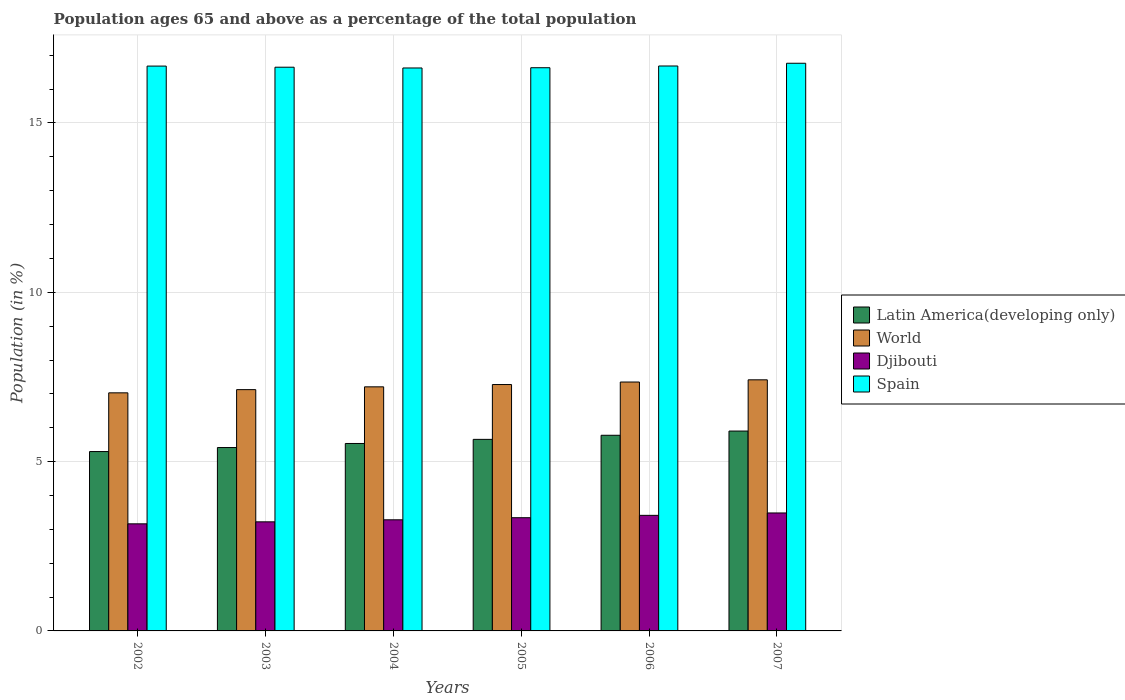How many different coloured bars are there?
Offer a very short reply. 4. Are the number of bars per tick equal to the number of legend labels?
Ensure brevity in your answer.  Yes. Are the number of bars on each tick of the X-axis equal?
Provide a short and direct response. Yes. In how many cases, is the number of bars for a given year not equal to the number of legend labels?
Keep it short and to the point. 0. What is the percentage of the population ages 65 and above in Djibouti in 2006?
Keep it short and to the point. 3.41. Across all years, what is the maximum percentage of the population ages 65 and above in World?
Provide a short and direct response. 7.41. Across all years, what is the minimum percentage of the population ages 65 and above in Djibouti?
Ensure brevity in your answer.  3.16. In which year was the percentage of the population ages 65 and above in World minimum?
Provide a short and direct response. 2002. What is the total percentage of the population ages 65 and above in Spain in the graph?
Provide a short and direct response. 100.03. What is the difference between the percentage of the population ages 65 and above in Latin America(developing only) in 2004 and that in 2005?
Your response must be concise. -0.12. What is the difference between the percentage of the population ages 65 and above in World in 2007 and the percentage of the population ages 65 and above in Spain in 2004?
Your response must be concise. -9.21. What is the average percentage of the population ages 65 and above in Latin America(developing only) per year?
Ensure brevity in your answer.  5.6. In the year 2002, what is the difference between the percentage of the population ages 65 and above in World and percentage of the population ages 65 and above in Spain?
Give a very brief answer. -9.65. What is the ratio of the percentage of the population ages 65 and above in Latin America(developing only) in 2006 to that in 2007?
Ensure brevity in your answer.  0.98. What is the difference between the highest and the second highest percentage of the population ages 65 and above in World?
Offer a terse response. 0.06. What is the difference between the highest and the lowest percentage of the population ages 65 and above in Djibouti?
Your response must be concise. 0.32. Is the sum of the percentage of the population ages 65 and above in Latin America(developing only) in 2003 and 2006 greater than the maximum percentage of the population ages 65 and above in Djibouti across all years?
Give a very brief answer. Yes. What does the 3rd bar from the left in 2002 represents?
Ensure brevity in your answer.  Djibouti. What does the 4th bar from the right in 2005 represents?
Provide a short and direct response. Latin America(developing only). Is it the case that in every year, the sum of the percentage of the population ages 65 and above in Djibouti and percentage of the population ages 65 and above in Latin America(developing only) is greater than the percentage of the population ages 65 and above in Spain?
Keep it short and to the point. No. What is the difference between two consecutive major ticks on the Y-axis?
Your answer should be very brief. 5. Does the graph contain any zero values?
Ensure brevity in your answer.  No. Does the graph contain grids?
Keep it short and to the point. Yes. Where does the legend appear in the graph?
Provide a succinct answer. Center right. How many legend labels are there?
Your answer should be compact. 4. How are the legend labels stacked?
Keep it short and to the point. Vertical. What is the title of the graph?
Make the answer very short. Population ages 65 and above as a percentage of the total population. What is the label or title of the Y-axis?
Your answer should be compact. Population (in %). What is the Population (in %) of Latin America(developing only) in 2002?
Your response must be concise. 5.3. What is the Population (in %) in World in 2002?
Your answer should be compact. 7.03. What is the Population (in %) of Djibouti in 2002?
Offer a very short reply. 3.16. What is the Population (in %) of Spain in 2002?
Your answer should be very brief. 16.68. What is the Population (in %) of Latin America(developing only) in 2003?
Offer a terse response. 5.42. What is the Population (in %) in World in 2003?
Keep it short and to the point. 7.13. What is the Population (in %) of Djibouti in 2003?
Provide a short and direct response. 3.22. What is the Population (in %) of Spain in 2003?
Your answer should be very brief. 16.65. What is the Population (in %) in Latin America(developing only) in 2004?
Ensure brevity in your answer.  5.54. What is the Population (in %) of World in 2004?
Provide a succinct answer. 7.21. What is the Population (in %) of Djibouti in 2004?
Provide a short and direct response. 3.28. What is the Population (in %) in Spain in 2004?
Your response must be concise. 16.62. What is the Population (in %) in Latin America(developing only) in 2005?
Your answer should be very brief. 5.66. What is the Population (in %) of World in 2005?
Provide a short and direct response. 7.28. What is the Population (in %) of Djibouti in 2005?
Give a very brief answer. 3.34. What is the Population (in %) of Spain in 2005?
Your response must be concise. 16.63. What is the Population (in %) of Latin America(developing only) in 2006?
Offer a very short reply. 5.78. What is the Population (in %) in World in 2006?
Provide a succinct answer. 7.35. What is the Population (in %) of Djibouti in 2006?
Provide a succinct answer. 3.41. What is the Population (in %) of Spain in 2006?
Make the answer very short. 16.68. What is the Population (in %) of Latin America(developing only) in 2007?
Offer a terse response. 5.9. What is the Population (in %) in World in 2007?
Give a very brief answer. 7.41. What is the Population (in %) in Djibouti in 2007?
Ensure brevity in your answer.  3.48. What is the Population (in %) in Spain in 2007?
Your answer should be very brief. 16.76. Across all years, what is the maximum Population (in %) of Latin America(developing only)?
Provide a succinct answer. 5.9. Across all years, what is the maximum Population (in %) in World?
Provide a succinct answer. 7.41. Across all years, what is the maximum Population (in %) in Djibouti?
Keep it short and to the point. 3.48. Across all years, what is the maximum Population (in %) of Spain?
Give a very brief answer. 16.76. Across all years, what is the minimum Population (in %) in Latin America(developing only)?
Give a very brief answer. 5.3. Across all years, what is the minimum Population (in %) in World?
Ensure brevity in your answer.  7.03. Across all years, what is the minimum Population (in %) of Djibouti?
Give a very brief answer. 3.16. Across all years, what is the minimum Population (in %) in Spain?
Provide a succinct answer. 16.62. What is the total Population (in %) in Latin America(developing only) in the graph?
Your answer should be very brief. 33.58. What is the total Population (in %) of World in the graph?
Keep it short and to the point. 43.4. What is the total Population (in %) of Djibouti in the graph?
Offer a terse response. 19.9. What is the total Population (in %) in Spain in the graph?
Provide a succinct answer. 100.03. What is the difference between the Population (in %) of Latin America(developing only) in 2002 and that in 2003?
Keep it short and to the point. -0.12. What is the difference between the Population (in %) of World in 2002 and that in 2003?
Give a very brief answer. -0.09. What is the difference between the Population (in %) of Djibouti in 2002 and that in 2003?
Offer a terse response. -0.06. What is the difference between the Population (in %) in Spain in 2002 and that in 2003?
Give a very brief answer. 0.03. What is the difference between the Population (in %) of Latin America(developing only) in 2002 and that in 2004?
Your answer should be very brief. -0.24. What is the difference between the Population (in %) of World in 2002 and that in 2004?
Provide a short and direct response. -0.18. What is the difference between the Population (in %) of Djibouti in 2002 and that in 2004?
Make the answer very short. -0.12. What is the difference between the Population (in %) in Spain in 2002 and that in 2004?
Ensure brevity in your answer.  0.06. What is the difference between the Population (in %) in Latin America(developing only) in 2002 and that in 2005?
Offer a terse response. -0.36. What is the difference between the Population (in %) in World in 2002 and that in 2005?
Offer a terse response. -0.24. What is the difference between the Population (in %) of Djibouti in 2002 and that in 2005?
Ensure brevity in your answer.  -0.18. What is the difference between the Population (in %) in Spain in 2002 and that in 2005?
Offer a terse response. 0.05. What is the difference between the Population (in %) in Latin America(developing only) in 2002 and that in 2006?
Your answer should be compact. -0.48. What is the difference between the Population (in %) of World in 2002 and that in 2006?
Your answer should be compact. -0.32. What is the difference between the Population (in %) of Djibouti in 2002 and that in 2006?
Ensure brevity in your answer.  -0.25. What is the difference between the Population (in %) of Spain in 2002 and that in 2006?
Provide a succinct answer. -0. What is the difference between the Population (in %) in Latin America(developing only) in 2002 and that in 2007?
Your response must be concise. -0.61. What is the difference between the Population (in %) in World in 2002 and that in 2007?
Provide a succinct answer. -0.38. What is the difference between the Population (in %) of Djibouti in 2002 and that in 2007?
Offer a very short reply. -0.32. What is the difference between the Population (in %) in Spain in 2002 and that in 2007?
Make the answer very short. -0.08. What is the difference between the Population (in %) of Latin America(developing only) in 2003 and that in 2004?
Your response must be concise. -0.12. What is the difference between the Population (in %) of World in 2003 and that in 2004?
Offer a very short reply. -0.08. What is the difference between the Population (in %) of Djibouti in 2003 and that in 2004?
Ensure brevity in your answer.  -0.06. What is the difference between the Population (in %) in Spain in 2003 and that in 2004?
Make the answer very short. 0.02. What is the difference between the Population (in %) in Latin America(developing only) in 2003 and that in 2005?
Your response must be concise. -0.24. What is the difference between the Population (in %) in World in 2003 and that in 2005?
Provide a succinct answer. -0.15. What is the difference between the Population (in %) in Djibouti in 2003 and that in 2005?
Your answer should be very brief. -0.12. What is the difference between the Population (in %) of Spain in 2003 and that in 2005?
Give a very brief answer. 0.02. What is the difference between the Population (in %) in Latin America(developing only) in 2003 and that in 2006?
Your answer should be very brief. -0.36. What is the difference between the Population (in %) in World in 2003 and that in 2006?
Provide a succinct answer. -0.22. What is the difference between the Population (in %) in Djibouti in 2003 and that in 2006?
Provide a short and direct response. -0.19. What is the difference between the Population (in %) of Spain in 2003 and that in 2006?
Your answer should be very brief. -0.04. What is the difference between the Population (in %) of Latin America(developing only) in 2003 and that in 2007?
Make the answer very short. -0.49. What is the difference between the Population (in %) in World in 2003 and that in 2007?
Offer a terse response. -0.29. What is the difference between the Population (in %) in Djibouti in 2003 and that in 2007?
Provide a short and direct response. -0.26. What is the difference between the Population (in %) in Spain in 2003 and that in 2007?
Give a very brief answer. -0.12. What is the difference between the Population (in %) in Latin America(developing only) in 2004 and that in 2005?
Provide a succinct answer. -0.12. What is the difference between the Population (in %) of World in 2004 and that in 2005?
Give a very brief answer. -0.07. What is the difference between the Population (in %) in Djibouti in 2004 and that in 2005?
Give a very brief answer. -0.06. What is the difference between the Population (in %) in Spain in 2004 and that in 2005?
Give a very brief answer. -0.01. What is the difference between the Population (in %) of Latin America(developing only) in 2004 and that in 2006?
Provide a short and direct response. -0.24. What is the difference between the Population (in %) in World in 2004 and that in 2006?
Offer a very short reply. -0.14. What is the difference between the Population (in %) in Djibouti in 2004 and that in 2006?
Offer a terse response. -0.13. What is the difference between the Population (in %) of Spain in 2004 and that in 2006?
Your answer should be compact. -0.06. What is the difference between the Population (in %) of Latin America(developing only) in 2004 and that in 2007?
Your response must be concise. -0.37. What is the difference between the Population (in %) in World in 2004 and that in 2007?
Ensure brevity in your answer.  -0.21. What is the difference between the Population (in %) in Djibouti in 2004 and that in 2007?
Give a very brief answer. -0.2. What is the difference between the Population (in %) in Spain in 2004 and that in 2007?
Provide a succinct answer. -0.14. What is the difference between the Population (in %) of Latin America(developing only) in 2005 and that in 2006?
Give a very brief answer. -0.12. What is the difference between the Population (in %) of World in 2005 and that in 2006?
Keep it short and to the point. -0.07. What is the difference between the Population (in %) of Djibouti in 2005 and that in 2006?
Ensure brevity in your answer.  -0.07. What is the difference between the Population (in %) of Spain in 2005 and that in 2006?
Give a very brief answer. -0.05. What is the difference between the Population (in %) of Latin America(developing only) in 2005 and that in 2007?
Make the answer very short. -0.25. What is the difference between the Population (in %) in World in 2005 and that in 2007?
Give a very brief answer. -0.14. What is the difference between the Population (in %) of Djibouti in 2005 and that in 2007?
Your answer should be very brief. -0.14. What is the difference between the Population (in %) of Spain in 2005 and that in 2007?
Your answer should be very brief. -0.13. What is the difference between the Population (in %) of Latin America(developing only) in 2006 and that in 2007?
Give a very brief answer. -0.12. What is the difference between the Population (in %) of World in 2006 and that in 2007?
Your answer should be compact. -0.06. What is the difference between the Population (in %) in Djibouti in 2006 and that in 2007?
Keep it short and to the point. -0.07. What is the difference between the Population (in %) of Spain in 2006 and that in 2007?
Your answer should be very brief. -0.08. What is the difference between the Population (in %) of Latin America(developing only) in 2002 and the Population (in %) of World in 2003?
Give a very brief answer. -1.83. What is the difference between the Population (in %) in Latin America(developing only) in 2002 and the Population (in %) in Djibouti in 2003?
Keep it short and to the point. 2.08. What is the difference between the Population (in %) of Latin America(developing only) in 2002 and the Population (in %) of Spain in 2003?
Provide a succinct answer. -11.35. What is the difference between the Population (in %) of World in 2002 and the Population (in %) of Djibouti in 2003?
Provide a short and direct response. 3.81. What is the difference between the Population (in %) of World in 2002 and the Population (in %) of Spain in 2003?
Offer a terse response. -9.62. What is the difference between the Population (in %) in Djibouti in 2002 and the Population (in %) in Spain in 2003?
Give a very brief answer. -13.48. What is the difference between the Population (in %) in Latin America(developing only) in 2002 and the Population (in %) in World in 2004?
Give a very brief answer. -1.91. What is the difference between the Population (in %) of Latin America(developing only) in 2002 and the Population (in %) of Djibouti in 2004?
Keep it short and to the point. 2.02. What is the difference between the Population (in %) in Latin America(developing only) in 2002 and the Population (in %) in Spain in 2004?
Your response must be concise. -11.33. What is the difference between the Population (in %) of World in 2002 and the Population (in %) of Djibouti in 2004?
Give a very brief answer. 3.75. What is the difference between the Population (in %) of World in 2002 and the Population (in %) of Spain in 2004?
Your response must be concise. -9.59. What is the difference between the Population (in %) in Djibouti in 2002 and the Population (in %) in Spain in 2004?
Your response must be concise. -13.46. What is the difference between the Population (in %) in Latin America(developing only) in 2002 and the Population (in %) in World in 2005?
Your response must be concise. -1.98. What is the difference between the Population (in %) of Latin America(developing only) in 2002 and the Population (in %) of Djibouti in 2005?
Your answer should be very brief. 1.95. What is the difference between the Population (in %) in Latin America(developing only) in 2002 and the Population (in %) in Spain in 2005?
Give a very brief answer. -11.33. What is the difference between the Population (in %) in World in 2002 and the Population (in %) in Djibouti in 2005?
Keep it short and to the point. 3.69. What is the difference between the Population (in %) in World in 2002 and the Population (in %) in Spain in 2005?
Give a very brief answer. -9.6. What is the difference between the Population (in %) of Djibouti in 2002 and the Population (in %) of Spain in 2005?
Your response must be concise. -13.47. What is the difference between the Population (in %) in Latin America(developing only) in 2002 and the Population (in %) in World in 2006?
Offer a very short reply. -2.05. What is the difference between the Population (in %) of Latin America(developing only) in 2002 and the Population (in %) of Djibouti in 2006?
Ensure brevity in your answer.  1.88. What is the difference between the Population (in %) in Latin America(developing only) in 2002 and the Population (in %) in Spain in 2006?
Your answer should be compact. -11.39. What is the difference between the Population (in %) in World in 2002 and the Population (in %) in Djibouti in 2006?
Offer a very short reply. 3.62. What is the difference between the Population (in %) in World in 2002 and the Population (in %) in Spain in 2006?
Offer a very short reply. -9.65. What is the difference between the Population (in %) in Djibouti in 2002 and the Population (in %) in Spain in 2006?
Ensure brevity in your answer.  -13.52. What is the difference between the Population (in %) of Latin America(developing only) in 2002 and the Population (in %) of World in 2007?
Your answer should be compact. -2.12. What is the difference between the Population (in %) in Latin America(developing only) in 2002 and the Population (in %) in Djibouti in 2007?
Give a very brief answer. 1.81. What is the difference between the Population (in %) of Latin America(developing only) in 2002 and the Population (in %) of Spain in 2007?
Keep it short and to the point. -11.47. What is the difference between the Population (in %) in World in 2002 and the Population (in %) in Djibouti in 2007?
Your response must be concise. 3.55. What is the difference between the Population (in %) in World in 2002 and the Population (in %) in Spain in 2007?
Your answer should be compact. -9.73. What is the difference between the Population (in %) of Djibouti in 2002 and the Population (in %) of Spain in 2007?
Your response must be concise. -13.6. What is the difference between the Population (in %) of Latin America(developing only) in 2003 and the Population (in %) of World in 2004?
Your response must be concise. -1.79. What is the difference between the Population (in %) of Latin America(developing only) in 2003 and the Population (in %) of Djibouti in 2004?
Your answer should be very brief. 2.13. What is the difference between the Population (in %) in Latin America(developing only) in 2003 and the Population (in %) in Spain in 2004?
Your response must be concise. -11.21. What is the difference between the Population (in %) in World in 2003 and the Population (in %) in Djibouti in 2004?
Make the answer very short. 3.84. What is the difference between the Population (in %) of World in 2003 and the Population (in %) of Spain in 2004?
Ensure brevity in your answer.  -9.5. What is the difference between the Population (in %) of Djibouti in 2003 and the Population (in %) of Spain in 2004?
Offer a terse response. -13.4. What is the difference between the Population (in %) of Latin America(developing only) in 2003 and the Population (in %) of World in 2005?
Your answer should be very brief. -1.86. What is the difference between the Population (in %) of Latin America(developing only) in 2003 and the Population (in %) of Djibouti in 2005?
Offer a terse response. 2.07. What is the difference between the Population (in %) in Latin America(developing only) in 2003 and the Population (in %) in Spain in 2005?
Your response must be concise. -11.22. What is the difference between the Population (in %) in World in 2003 and the Population (in %) in Djibouti in 2005?
Offer a terse response. 3.78. What is the difference between the Population (in %) in World in 2003 and the Population (in %) in Spain in 2005?
Offer a terse response. -9.51. What is the difference between the Population (in %) of Djibouti in 2003 and the Population (in %) of Spain in 2005?
Your answer should be very brief. -13.41. What is the difference between the Population (in %) in Latin America(developing only) in 2003 and the Population (in %) in World in 2006?
Provide a succinct answer. -1.93. What is the difference between the Population (in %) in Latin America(developing only) in 2003 and the Population (in %) in Djibouti in 2006?
Offer a very short reply. 2. What is the difference between the Population (in %) of Latin America(developing only) in 2003 and the Population (in %) of Spain in 2006?
Make the answer very short. -11.27. What is the difference between the Population (in %) in World in 2003 and the Population (in %) in Djibouti in 2006?
Give a very brief answer. 3.71. What is the difference between the Population (in %) in World in 2003 and the Population (in %) in Spain in 2006?
Provide a short and direct response. -9.56. What is the difference between the Population (in %) in Djibouti in 2003 and the Population (in %) in Spain in 2006?
Provide a succinct answer. -13.46. What is the difference between the Population (in %) of Latin America(developing only) in 2003 and the Population (in %) of World in 2007?
Provide a short and direct response. -2. What is the difference between the Population (in %) of Latin America(developing only) in 2003 and the Population (in %) of Djibouti in 2007?
Offer a very short reply. 1.93. What is the difference between the Population (in %) in Latin America(developing only) in 2003 and the Population (in %) in Spain in 2007?
Offer a terse response. -11.35. What is the difference between the Population (in %) of World in 2003 and the Population (in %) of Djibouti in 2007?
Your response must be concise. 3.64. What is the difference between the Population (in %) of World in 2003 and the Population (in %) of Spain in 2007?
Provide a short and direct response. -9.64. What is the difference between the Population (in %) in Djibouti in 2003 and the Population (in %) in Spain in 2007?
Ensure brevity in your answer.  -13.54. What is the difference between the Population (in %) of Latin America(developing only) in 2004 and the Population (in %) of World in 2005?
Provide a short and direct response. -1.74. What is the difference between the Population (in %) in Latin America(developing only) in 2004 and the Population (in %) in Djibouti in 2005?
Offer a very short reply. 2.19. What is the difference between the Population (in %) in Latin America(developing only) in 2004 and the Population (in %) in Spain in 2005?
Your response must be concise. -11.1. What is the difference between the Population (in %) in World in 2004 and the Population (in %) in Djibouti in 2005?
Give a very brief answer. 3.87. What is the difference between the Population (in %) in World in 2004 and the Population (in %) in Spain in 2005?
Ensure brevity in your answer.  -9.42. What is the difference between the Population (in %) of Djibouti in 2004 and the Population (in %) of Spain in 2005?
Offer a very short reply. -13.35. What is the difference between the Population (in %) of Latin America(developing only) in 2004 and the Population (in %) of World in 2006?
Keep it short and to the point. -1.81. What is the difference between the Population (in %) in Latin America(developing only) in 2004 and the Population (in %) in Djibouti in 2006?
Make the answer very short. 2.12. What is the difference between the Population (in %) of Latin America(developing only) in 2004 and the Population (in %) of Spain in 2006?
Ensure brevity in your answer.  -11.15. What is the difference between the Population (in %) of World in 2004 and the Population (in %) of Djibouti in 2006?
Your answer should be compact. 3.8. What is the difference between the Population (in %) in World in 2004 and the Population (in %) in Spain in 2006?
Provide a succinct answer. -9.47. What is the difference between the Population (in %) of Djibouti in 2004 and the Population (in %) of Spain in 2006?
Your answer should be compact. -13.4. What is the difference between the Population (in %) in Latin America(developing only) in 2004 and the Population (in %) in World in 2007?
Your answer should be very brief. -1.88. What is the difference between the Population (in %) of Latin America(developing only) in 2004 and the Population (in %) of Djibouti in 2007?
Ensure brevity in your answer.  2.05. What is the difference between the Population (in %) of Latin America(developing only) in 2004 and the Population (in %) of Spain in 2007?
Make the answer very short. -11.23. What is the difference between the Population (in %) of World in 2004 and the Population (in %) of Djibouti in 2007?
Ensure brevity in your answer.  3.72. What is the difference between the Population (in %) in World in 2004 and the Population (in %) in Spain in 2007?
Give a very brief answer. -9.56. What is the difference between the Population (in %) in Djibouti in 2004 and the Population (in %) in Spain in 2007?
Give a very brief answer. -13.48. What is the difference between the Population (in %) in Latin America(developing only) in 2005 and the Population (in %) in World in 2006?
Offer a very short reply. -1.69. What is the difference between the Population (in %) of Latin America(developing only) in 2005 and the Population (in %) of Djibouti in 2006?
Keep it short and to the point. 2.24. What is the difference between the Population (in %) of Latin America(developing only) in 2005 and the Population (in %) of Spain in 2006?
Your answer should be compact. -11.03. What is the difference between the Population (in %) of World in 2005 and the Population (in %) of Djibouti in 2006?
Your answer should be compact. 3.86. What is the difference between the Population (in %) in World in 2005 and the Population (in %) in Spain in 2006?
Make the answer very short. -9.41. What is the difference between the Population (in %) in Djibouti in 2005 and the Population (in %) in Spain in 2006?
Provide a short and direct response. -13.34. What is the difference between the Population (in %) in Latin America(developing only) in 2005 and the Population (in %) in World in 2007?
Offer a terse response. -1.76. What is the difference between the Population (in %) in Latin America(developing only) in 2005 and the Population (in %) in Djibouti in 2007?
Offer a very short reply. 2.17. What is the difference between the Population (in %) of Latin America(developing only) in 2005 and the Population (in %) of Spain in 2007?
Your answer should be compact. -11.11. What is the difference between the Population (in %) in World in 2005 and the Population (in %) in Djibouti in 2007?
Make the answer very short. 3.79. What is the difference between the Population (in %) of World in 2005 and the Population (in %) of Spain in 2007?
Keep it short and to the point. -9.49. What is the difference between the Population (in %) in Djibouti in 2005 and the Population (in %) in Spain in 2007?
Give a very brief answer. -13.42. What is the difference between the Population (in %) of Latin America(developing only) in 2006 and the Population (in %) of World in 2007?
Your response must be concise. -1.64. What is the difference between the Population (in %) of Latin America(developing only) in 2006 and the Population (in %) of Djibouti in 2007?
Your response must be concise. 2.29. What is the difference between the Population (in %) of Latin America(developing only) in 2006 and the Population (in %) of Spain in 2007?
Provide a succinct answer. -10.99. What is the difference between the Population (in %) in World in 2006 and the Population (in %) in Djibouti in 2007?
Provide a succinct answer. 3.87. What is the difference between the Population (in %) of World in 2006 and the Population (in %) of Spain in 2007?
Give a very brief answer. -9.41. What is the difference between the Population (in %) in Djibouti in 2006 and the Population (in %) in Spain in 2007?
Offer a very short reply. -13.35. What is the average Population (in %) in Latin America(developing only) per year?
Provide a succinct answer. 5.6. What is the average Population (in %) of World per year?
Your answer should be compact. 7.23. What is the average Population (in %) of Djibouti per year?
Make the answer very short. 3.32. What is the average Population (in %) in Spain per year?
Offer a very short reply. 16.67. In the year 2002, what is the difference between the Population (in %) in Latin America(developing only) and Population (in %) in World?
Ensure brevity in your answer.  -1.73. In the year 2002, what is the difference between the Population (in %) of Latin America(developing only) and Population (in %) of Djibouti?
Offer a terse response. 2.13. In the year 2002, what is the difference between the Population (in %) in Latin America(developing only) and Population (in %) in Spain?
Your answer should be compact. -11.38. In the year 2002, what is the difference between the Population (in %) in World and Population (in %) in Djibouti?
Provide a short and direct response. 3.87. In the year 2002, what is the difference between the Population (in %) of World and Population (in %) of Spain?
Offer a very short reply. -9.65. In the year 2002, what is the difference between the Population (in %) of Djibouti and Population (in %) of Spain?
Offer a very short reply. -13.52. In the year 2003, what is the difference between the Population (in %) in Latin America(developing only) and Population (in %) in World?
Make the answer very short. -1.71. In the year 2003, what is the difference between the Population (in %) of Latin America(developing only) and Population (in %) of Djibouti?
Make the answer very short. 2.19. In the year 2003, what is the difference between the Population (in %) in Latin America(developing only) and Population (in %) in Spain?
Give a very brief answer. -11.23. In the year 2003, what is the difference between the Population (in %) in World and Population (in %) in Djibouti?
Make the answer very short. 3.9. In the year 2003, what is the difference between the Population (in %) of World and Population (in %) of Spain?
Ensure brevity in your answer.  -9.52. In the year 2003, what is the difference between the Population (in %) of Djibouti and Population (in %) of Spain?
Offer a terse response. -13.43. In the year 2004, what is the difference between the Population (in %) in Latin America(developing only) and Population (in %) in World?
Offer a terse response. -1.67. In the year 2004, what is the difference between the Population (in %) in Latin America(developing only) and Population (in %) in Djibouti?
Offer a very short reply. 2.25. In the year 2004, what is the difference between the Population (in %) in Latin America(developing only) and Population (in %) in Spain?
Keep it short and to the point. -11.09. In the year 2004, what is the difference between the Population (in %) of World and Population (in %) of Djibouti?
Make the answer very short. 3.93. In the year 2004, what is the difference between the Population (in %) in World and Population (in %) in Spain?
Provide a succinct answer. -9.42. In the year 2004, what is the difference between the Population (in %) in Djibouti and Population (in %) in Spain?
Keep it short and to the point. -13.34. In the year 2005, what is the difference between the Population (in %) in Latin America(developing only) and Population (in %) in World?
Your answer should be compact. -1.62. In the year 2005, what is the difference between the Population (in %) in Latin America(developing only) and Population (in %) in Djibouti?
Make the answer very short. 2.31. In the year 2005, what is the difference between the Population (in %) of Latin America(developing only) and Population (in %) of Spain?
Your answer should be compact. -10.97. In the year 2005, what is the difference between the Population (in %) in World and Population (in %) in Djibouti?
Offer a very short reply. 3.93. In the year 2005, what is the difference between the Population (in %) in World and Population (in %) in Spain?
Make the answer very short. -9.36. In the year 2005, what is the difference between the Population (in %) in Djibouti and Population (in %) in Spain?
Your answer should be very brief. -13.29. In the year 2006, what is the difference between the Population (in %) of Latin America(developing only) and Population (in %) of World?
Offer a terse response. -1.57. In the year 2006, what is the difference between the Population (in %) of Latin America(developing only) and Population (in %) of Djibouti?
Keep it short and to the point. 2.36. In the year 2006, what is the difference between the Population (in %) of Latin America(developing only) and Population (in %) of Spain?
Make the answer very short. -10.9. In the year 2006, what is the difference between the Population (in %) in World and Population (in %) in Djibouti?
Give a very brief answer. 3.94. In the year 2006, what is the difference between the Population (in %) of World and Population (in %) of Spain?
Offer a terse response. -9.33. In the year 2006, what is the difference between the Population (in %) of Djibouti and Population (in %) of Spain?
Provide a short and direct response. -13.27. In the year 2007, what is the difference between the Population (in %) of Latin America(developing only) and Population (in %) of World?
Make the answer very short. -1.51. In the year 2007, what is the difference between the Population (in %) in Latin America(developing only) and Population (in %) in Djibouti?
Offer a very short reply. 2.42. In the year 2007, what is the difference between the Population (in %) in Latin America(developing only) and Population (in %) in Spain?
Offer a very short reply. -10.86. In the year 2007, what is the difference between the Population (in %) in World and Population (in %) in Djibouti?
Provide a short and direct response. 3.93. In the year 2007, what is the difference between the Population (in %) in World and Population (in %) in Spain?
Give a very brief answer. -9.35. In the year 2007, what is the difference between the Population (in %) of Djibouti and Population (in %) of Spain?
Offer a terse response. -13.28. What is the ratio of the Population (in %) of Latin America(developing only) in 2002 to that in 2003?
Your answer should be compact. 0.98. What is the ratio of the Population (in %) of World in 2002 to that in 2003?
Offer a terse response. 0.99. What is the ratio of the Population (in %) of Djibouti in 2002 to that in 2003?
Offer a very short reply. 0.98. What is the ratio of the Population (in %) of Latin America(developing only) in 2002 to that in 2004?
Offer a very short reply. 0.96. What is the ratio of the Population (in %) in World in 2002 to that in 2004?
Offer a very short reply. 0.98. What is the ratio of the Population (in %) in Djibouti in 2002 to that in 2004?
Offer a terse response. 0.96. What is the ratio of the Population (in %) of Latin America(developing only) in 2002 to that in 2005?
Make the answer very short. 0.94. What is the ratio of the Population (in %) in World in 2002 to that in 2005?
Make the answer very short. 0.97. What is the ratio of the Population (in %) of Djibouti in 2002 to that in 2005?
Give a very brief answer. 0.95. What is the ratio of the Population (in %) of Spain in 2002 to that in 2005?
Provide a succinct answer. 1. What is the ratio of the Population (in %) of World in 2002 to that in 2006?
Ensure brevity in your answer.  0.96. What is the ratio of the Population (in %) in Djibouti in 2002 to that in 2006?
Your answer should be very brief. 0.93. What is the ratio of the Population (in %) in Spain in 2002 to that in 2006?
Your answer should be very brief. 1. What is the ratio of the Population (in %) in Latin America(developing only) in 2002 to that in 2007?
Make the answer very short. 0.9. What is the ratio of the Population (in %) of World in 2002 to that in 2007?
Provide a succinct answer. 0.95. What is the ratio of the Population (in %) in Djibouti in 2002 to that in 2007?
Keep it short and to the point. 0.91. What is the ratio of the Population (in %) in Spain in 2002 to that in 2007?
Ensure brevity in your answer.  0.99. What is the ratio of the Population (in %) in Latin America(developing only) in 2003 to that in 2004?
Provide a succinct answer. 0.98. What is the ratio of the Population (in %) in World in 2003 to that in 2004?
Provide a succinct answer. 0.99. What is the ratio of the Population (in %) of Djibouti in 2003 to that in 2004?
Give a very brief answer. 0.98. What is the ratio of the Population (in %) of Spain in 2003 to that in 2004?
Your answer should be compact. 1. What is the ratio of the Population (in %) in Latin America(developing only) in 2003 to that in 2005?
Offer a terse response. 0.96. What is the ratio of the Population (in %) in World in 2003 to that in 2005?
Make the answer very short. 0.98. What is the ratio of the Population (in %) in Djibouti in 2003 to that in 2005?
Ensure brevity in your answer.  0.96. What is the ratio of the Population (in %) in Latin America(developing only) in 2003 to that in 2006?
Make the answer very short. 0.94. What is the ratio of the Population (in %) in World in 2003 to that in 2006?
Provide a succinct answer. 0.97. What is the ratio of the Population (in %) of Djibouti in 2003 to that in 2006?
Provide a succinct answer. 0.94. What is the ratio of the Population (in %) of Spain in 2003 to that in 2006?
Keep it short and to the point. 1. What is the ratio of the Population (in %) in Latin America(developing only) in 2003 to that in 2007?
Ensure brevity in your answer.  0.92. What is the ratio of the Population (in %) of World in 2003 to that in 2007?
Keep it short and to the point. 0.96. What is the ratio of the Population (in %) of Djibouti in 2003 to that in 2007?
Your response must be concise. 0.92. What is the ratio of the Population (in %) in Latin America(developing only) in 2004 to that in 2005?
Your answer should be very brief. 0.98. What is the ratio of the Population (in %) in Djibouti in 2004 to that in 2005?
Your answer should be very brief. 0.98. What is the ratio of the Population (in %) in Latin America(developing only) in 2004 to that in 2006?
Your response must be concise. 0.96. What is the ratio of the Population (in %) in World in 2004 to that in 2006?
Provide a short and direct response. 0.98. What is the ratio of the Population (in %) in Djibouti in 2004 to that in 2006?
Keep it short and to the point. 0.96. What is the ratio of the Population (in %) of Spain in 2004 to that in 2006?
Provide a short and direct response. 1. What is the ratio of the Population (in %) of Latin America(developing only) in 2004 to that in 2007?
Offer a terse response. 0.94. What is the ratio of the Population (in %) in World in 2004 to that in 2007?
Your answer should be compact. 0.97. What is the ratio of the Population (in %) in Djibouti in 2004 to that in 2007?
Give a very brief answer. 0.94. What is the ratio of the Population (in %) of Spain in 2004 to that in 2007?
Offer a terse response. 0.99. What is the ratio of the Population (in %) of Latin America(developing only) in 2005 to that in 2006?
Provide a short and direct response. 0.98. What is the ratio of the Population (in %) of World in 2005 to that in 2006?
Give a very brief answer. 0.99. What is the ratio of the Population (in %) in Djibouti in 2005 to that in 2006?
Your answer should be very brief. 0.98. What is the ratio of the Population (in %) of World in 2005 to that in 2007?
Provide a succinct answer. 0.98. What is the ratio of the Population (in %) of Djibouti in 2005 to that in 2007?
Offer a terse response. 0.96. What is the ratio of the Population (in %) of Latin America(developing only) in 2006 to that in 2007?
Your answer should be compact. 0.98. What is the ratio of the Population (in %) in World in 2006 to that in 2007?
Offer a very short reply. 0.99. What is the ratio of the Population (in %) in Djibouti in 2006 to that in 2007?
Provide a short and direct response. 0.98. What is the difference between the highest and the second highest Population (in %) of Latin America(developing only)?
Offer a terse response. 0.12. What is the difference between the highest and the second highest Population (in %) in World?
Your answer should be very brief. 0.06. What is the difference between the highest and the second highest Population (in %) in Djibouti?
Offer a very short reply. 0.07. What is the difference between the highest and the second highest Population (in %) of Spain?
Your answer should be compact. 0.08. What is the difference between the highest and the lowest Population (in %) in Latin America(developing only)?
Offer a terse response. 0.61. What is the difference between the highest and the lowest Population (in %) of World?
Offer a very short reply. 0.38. What is the difference between the highest and the lowest Population (in %) of Djibouti?
Your answer should be very brief. 0.32. What is the difference between the highest and the lowest Population (in %) of Spain?
Your response must be concise. 0.14. 